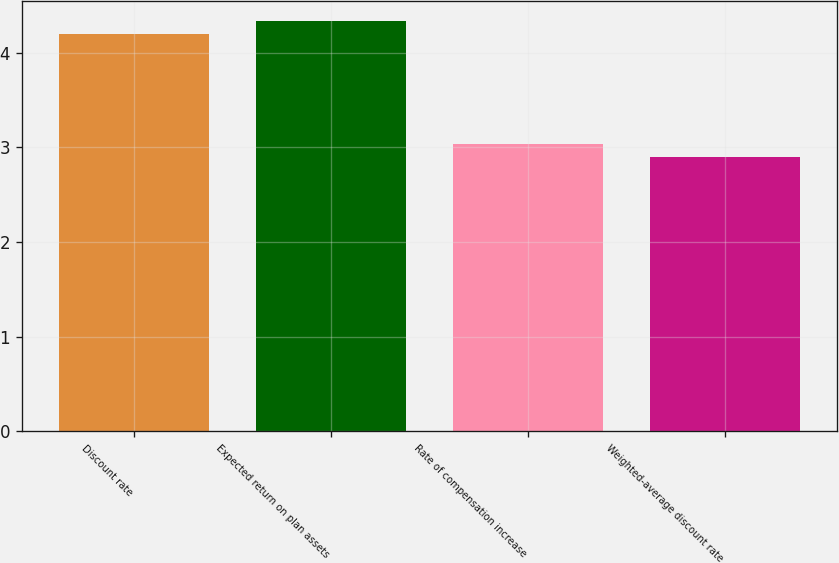<chart> <loc_0><loc_0><loc_500><loc_500><bar_chart><fcel>Discount rate<fcel>Expected return on plan assets<fcel>Rate of compensation increase<fcel>Weighted-average discount rate<nl><fcel>4.2<fcel>4.33<fcel>3.03<fcel>2.9<nl></chart> 